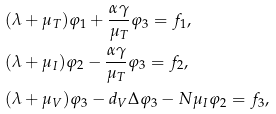<formula> <loc_0><loc_0><loc_500><loc_500>& ( \lambda + \mu _ { T } ) \varphi _ { 1 } + \frac { \alpha \gamma } { \mu _ { T } } \varphi _ { 3 } = f _ { 1 } , \\ & ( \lambda + \mu _ { I } ) \varphi _ { 2 } - \frac { \alpha \gamma } { \mu _ { T } } \varphi _ { 3 } = f _ { 2 } , \\ & ( \lambda + \mu _ { V } ) \varphi _ { 3 } - d _ { V } \Delta \varphi _ { 3 } - N \mu _ { I } \varphi _ { 2 } = f _ { 3 } ,</formula> 